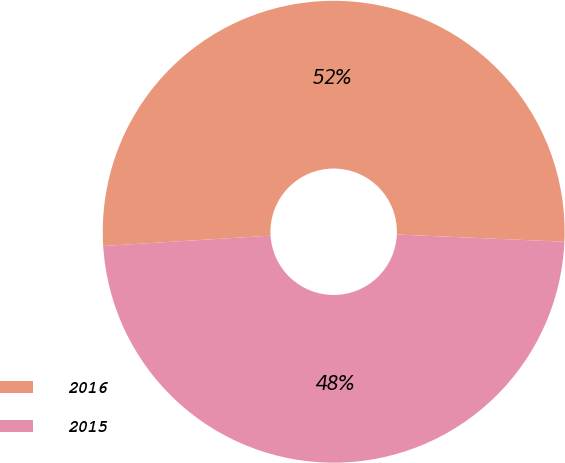<chart> <loc_0><loc_0><loc_500><loc_500><pie_chart><fcel>2016<fcel>2015<nl><fcel>51.67%<fcel>48.33%<nl></chart> 